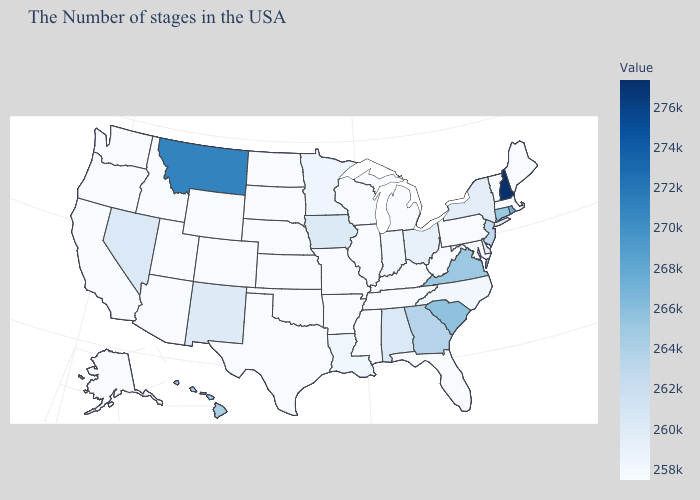Is the legend a continuous bar?
Short answer required. Yes. Which states hav the highest value in the West?
Short answer required. Montana. Among the states that border Florida , does Alabama have the lowest value?
Write a very short answer. Yes. Does Alabama have the lowest value in the USA?
Give a very brief answer. No. 